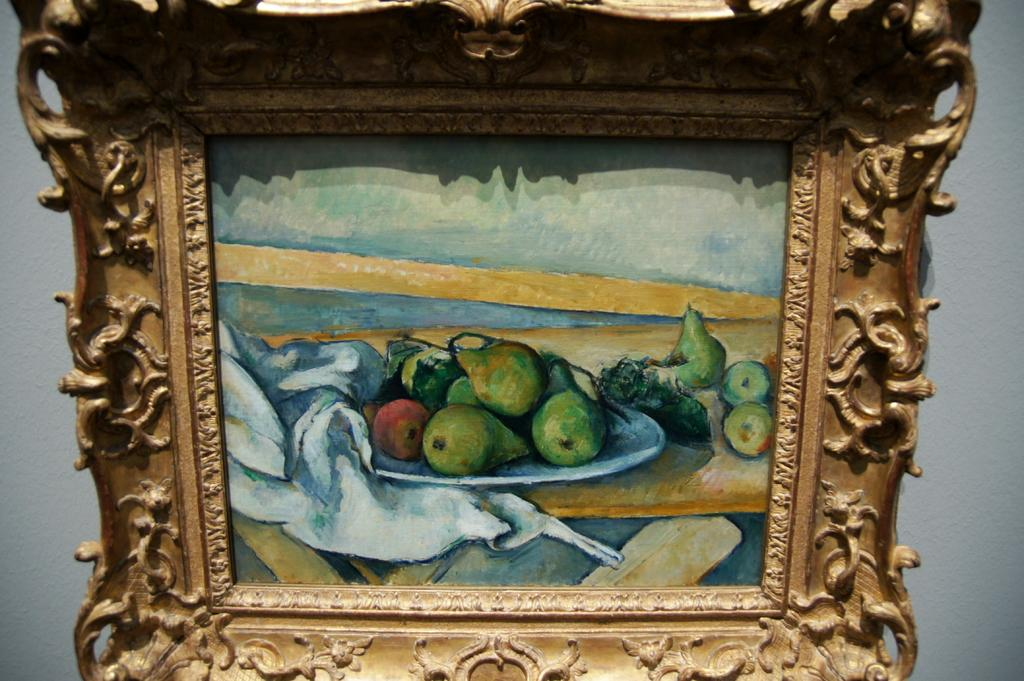What is the main object in the center of the image? There is a photo frame in the center of the image. What is placed on top of the photo frame? There is a plate on the photo frame. What is on the plate? There are fruits on the plate. What can be seen in the background of the image? There is a wall in the background of the image. What type of oil is being used to clean the beast in the image? There is no beast or oil present in the image; it features a photo frame with a plate of fruits on a wall. 